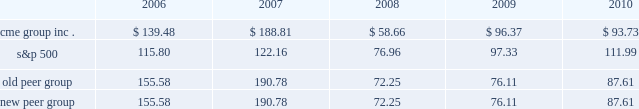Performance graph the following graph compares the cumulative five-year total return provided shareholders on our class a common stock relative to the cumulative total returns of the s&p 500 index and two customized peer groups .
The old peer group includes intercontinentalexchange , inc. , nyse euronext and the nasdaq omx group inc .
The new peer group is the same as the old peer group with the addition of cboe holdings , inc .
Which completed its initial public offering in june 2010 .
An investment of $ 100 ( with reinvestment of all dividends ) is assumed to have been made in our class a common stock , in the peer groups and the s&p 500 index on december 31 , 2005 and its relative performance is tracked through december 31 , 2010 .
Comparison of 5 year cumulative total return* among cme group inc. , the s&p 500 index , an old peer group and a new peer group 12/05 12/06 12/07 12/08 12/09 12/10 cme group inc .
S&p 500 old peer group *$ 100 invested on 12/31/05 in stock or index , including reinvestment of dividends .
Fiscal year ending december 31 .
Copyright a9 2011 s&p , a division of the mcgraw-hill companies inc .
All rights reserved .
New peer group the stock price performance included in this graph is not necessarily indicative of future stock price performance .

Did the cme group outperform the new peer group? 
Computations: (93.73 > 87.61)
Answer: yes. 